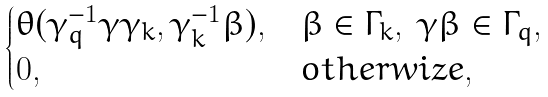Convert formula to latex. <formula><loc_0><loc_0><loc_500><loc_500>\begin{cases} \theta ( \gamma _ { q } ^ { - 1 } \gamma \gamma _ { k } , \gamma _ { k } ^ { - 1 } \beta ) , & \beta \in \Gamma _ { k } , \ \gamma \beta \in \Gamma _ { q } , \\ 0 , & o t h e r w i z e , \end{cases}</formula> 